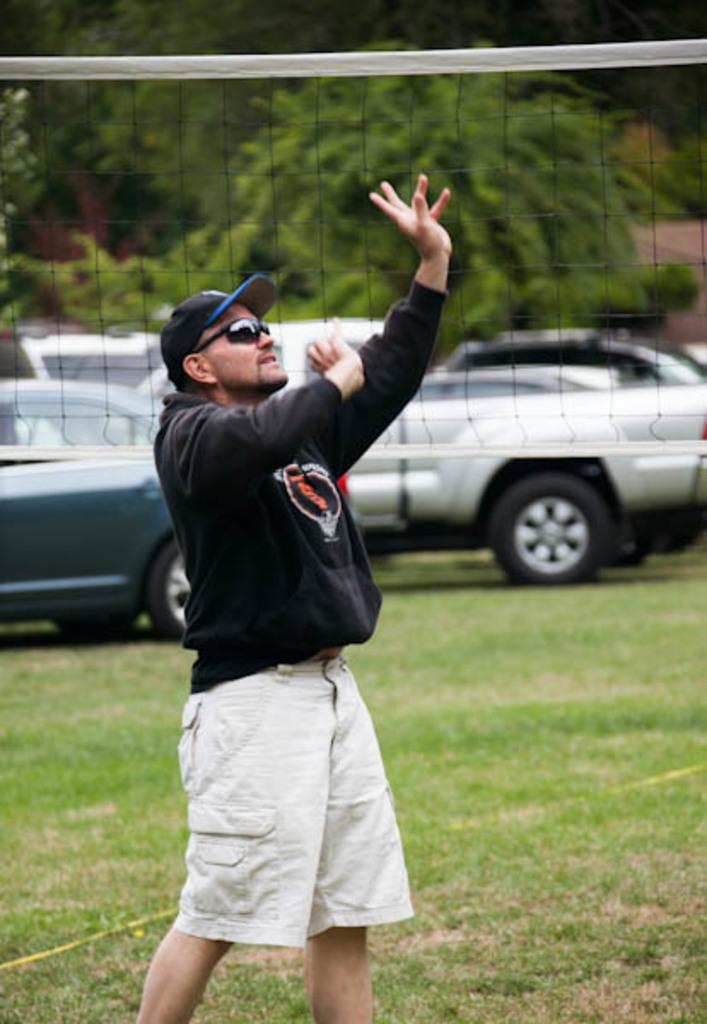What types of vehicles can be seen in the image? There are cars and vehicles in the image. Can you describe the person in the image? There is a man standing in the image. What is the ground covered with in the image? Grass is present on the ground. What other natural elements are visible in the image? There are trees in the image. What object can be seen in the back of the image? There is a net visible in the back of the image. What color is the secretary's sock in the image? There is no secretary or sock present in the image. 